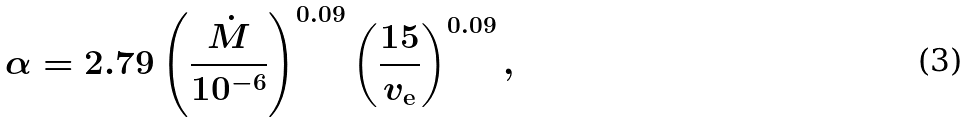Convert formula to latex. <formula><loc_0><loc_0><loc_500><loc_500>\alpha = 2 . 7 9 \left ( \frac { \dot { M } } { 1 0 ^ { - 6 } } \right ) ^ { 0 . 0 9 } \left ( \frac { 1 5 } { v _ { \mathrm e } } \right ) ^ { 0 . 0 9 } ,</formula> 